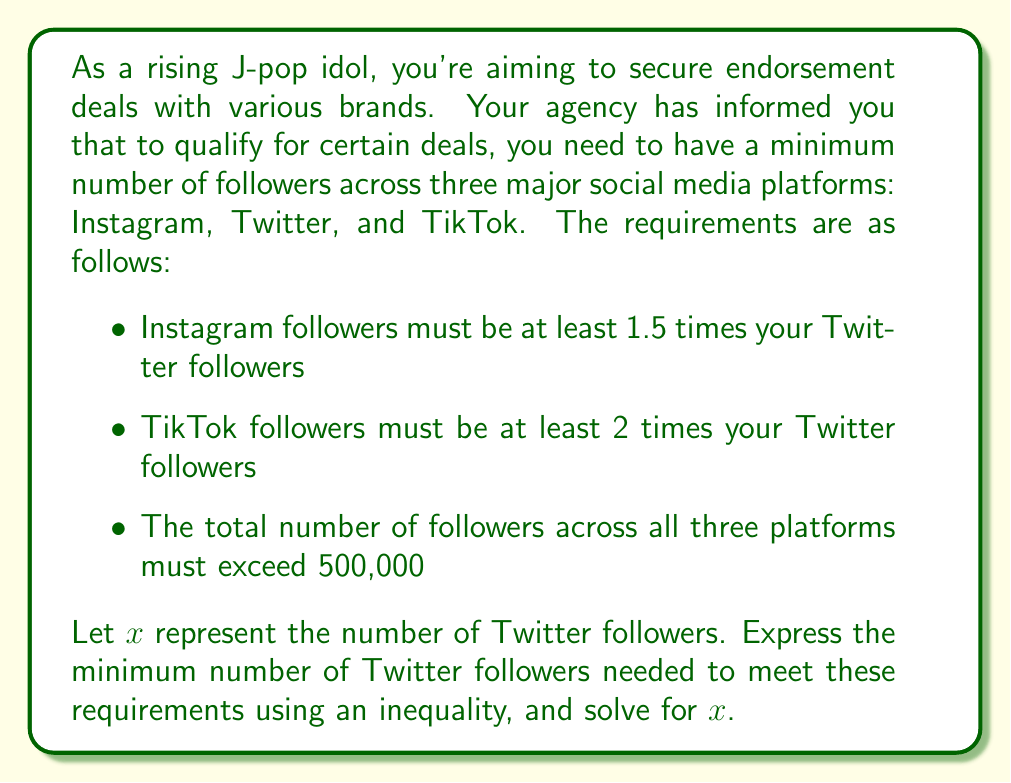Show me your answer to this math problem. Let's approach this step-by-step:

1) Let $x$ = number of Twitter followers

2) Based on the given information:
   Instagram followers ≥ 1.5x
   TikTok followers ≥ 2x

3) The total number of followers across all platforms must exceed 500,000:
   $x + 1.5x + 2x > 500,000$

4) Simplify the left side of the inequality:
   $4.5x > 500,000$

5) Solve for $x$:
   $$x > \frac{500,000}{4.5}$$
   $$x > 111,111.11$$

6) Since we're dealing with followers, which must be whole numbers, we need to round up to the nearest integer:
   $x ≥ 111,112$

Therefore, you need at least 111,112 Twitter followers to meet the minimum requirements for these endorsement deals.
Answer: The minimum number of Twitter followers required is 111,112. 